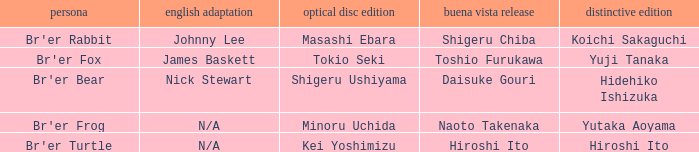What is the special edition for the english version of james baskett? Yuji Tanaka. 